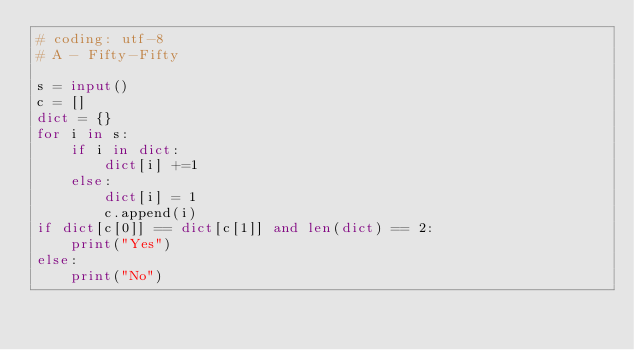Convert code to text. <code><loc_0><loc_0><loc_500><loc_500><_Python_># coding: utf-8
# A - Fifty-Fifty

s = input()
c = []
dict = {}
for i in s:
    if i in dict:
        dict[i] +=1
    else:
        dict[i] = 1
        c.append(i)
if dict[c[0]] == dict[c[1]] and len(dict) == 2:
    print("Yes")
else:
    print("No")
</code> 